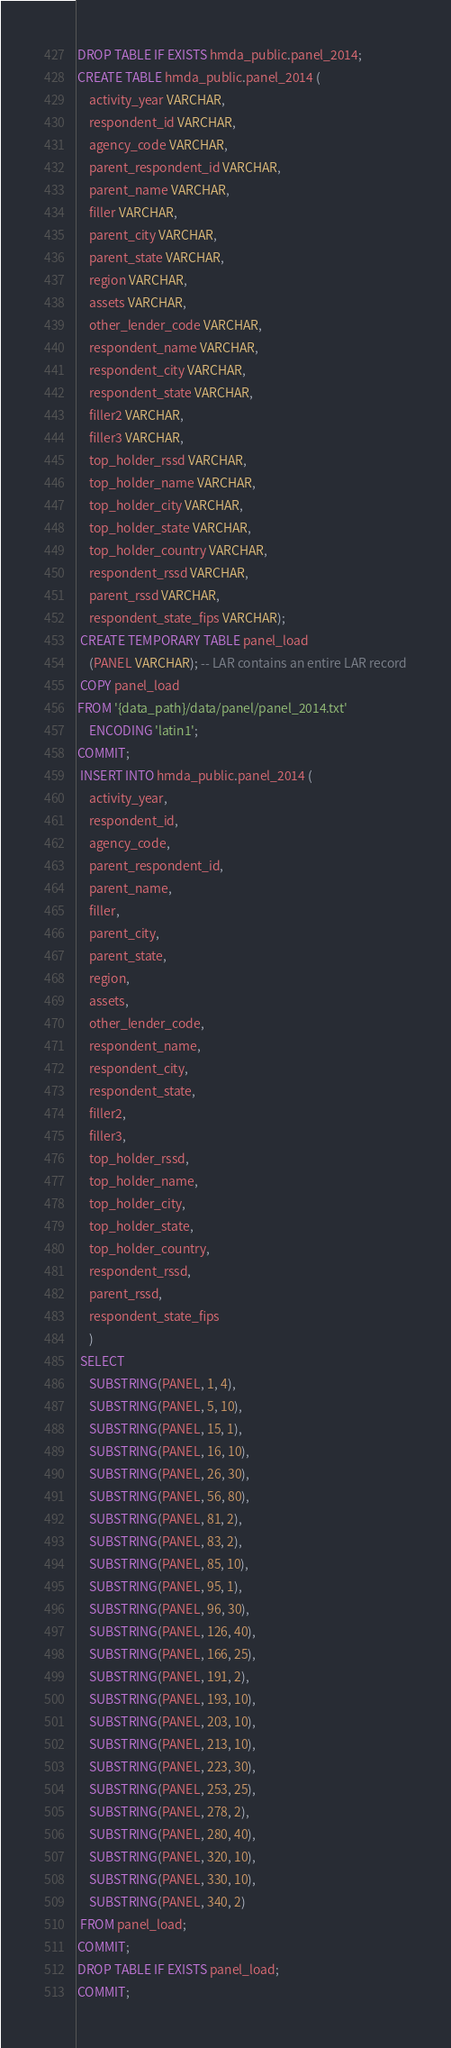<code> <loc_0><loc_0><loc_500><loc_500><_SQL_>DROP TABLE IF EXISTS hmda_public.panel_2014;
CREATE TABLE hmda_public.panel_2014 (
    activity_year VARCHAR,
    respondent_id VARCHAR,
    agency_code VARCHAR,
    parent_respondent_id VARCHAR,
    parent_name VARCHAR,
    filler VARCHAR,
    parent_city VARCHAR,
    parent_state VARCHAR,
    region VARCHAR,
    assets VARCHAR,
    other_lender_code VARCHAR,
    respondent_name VARCHAR,
    respondent_city VARCHAR,
    respondent_state VARCHAR,
    filler2 VARCHAR,
    filler3 VARCHAR,
    top_holder_rssd VARCHAR,
    top_holder_name VARCHAR,
    top_holder_city VARCHAR,
    top_holder_state VARCHAR,
    top_holder_country VARCHAR,
    respondent_rssd VARCHAR,
    parent_rssd VARCHAR,
    respondent_state_fips VARCHAR);
 CREATE TEMPORARY TABLE panel_load
    (PANEL VARCHAR); -- LAR contains an entire LAR record
 COPY panel_load
FROM '{data_path}/data/panel/panel_2014.txt' 
    ENCODING 'latin1';
COMMIT;
 INSERT INTO hmda_public.panel_2014 (
    activity_year,
    respondent_id,
    agency_code,
    parent_respondent_id,
    parent_name,
    filler,
    parent_city,
    parent_state,
    region,
    assets,
    other_lender_code,
    respondent_name,
    respondent_city,
    respondent_state,
    filler2,
    filler3,
    top_holder_rssd,
    top_holder_name,
    top_holder_city,
    top_holder_state,
    top_holder_country,
    respondent_rssd,
    parent_rssd,
    respondent_state_fips
    )
 SELECT 
    SUBSTRING(PANEL, 1, 4),
    SUBSTRING(PANEL, 5, 10),
    SUBSTRING(PANEL, 15, 1),
    SUBSTRING(PANEL, 16, 10),
    SUBSTRING(PANEL, 26, 30),
    SUBSTRING(PANEL, 56, 80),
    SUBSTRING(PANEL, 81, 2),
    SUBSTRING(PANEL, 83, 2),
    SUBSTRING(PANEL, 85, 10),
    SUBSTRING(PANEL, 95, 1),
    SUBSTRING(PANEL, 96, 30),
    SUBSTRING(PANEL, 126, 40),
    SUBSTRING(PANEL, 166, 25),
    SUBSTRING(PANEL, 191, 2),
    SUBSTRING(PANEL, 193, 10),
    SUBSTRING(PANEL, 203, 10),
    SUBSTRING(PANEL, 213, 10),
    SUBSTRING(PANEL, 223, 30),
    SUBSTRING(PANEL, 253, 25),
    SUBSTRING(PANEL, 278, 2),
    SUBSTRING(PANEL, 280, 40),
    SUBSTRING(PANEL, 320, 10),
    SUBSTRING(PANEL, 330, 10),
    SUBSTRING(PANEL, 340, 2)
 FROM panel_load;
COMMIT;
DROP TABLE IF EXISTS panel_load; 
COMMIT;
</code> 